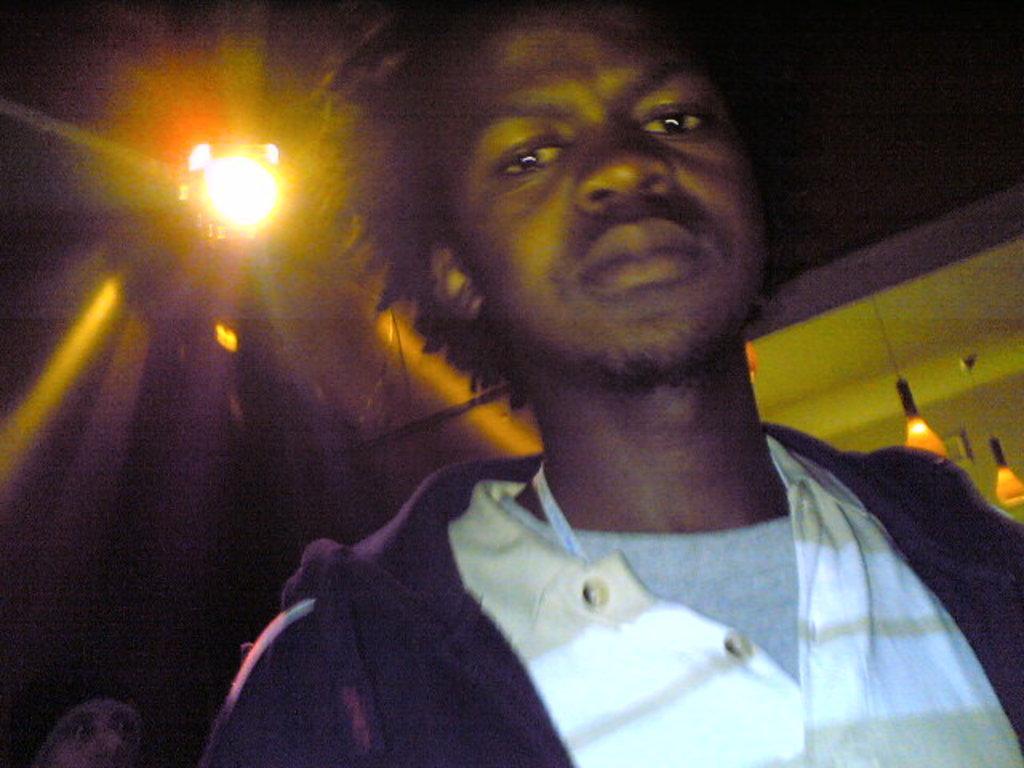Could you give a brief overview of what you see in this image? There is a person in brown color jacket, standing. In the background, there are lights attached to the roof. And the background is dark in color. 